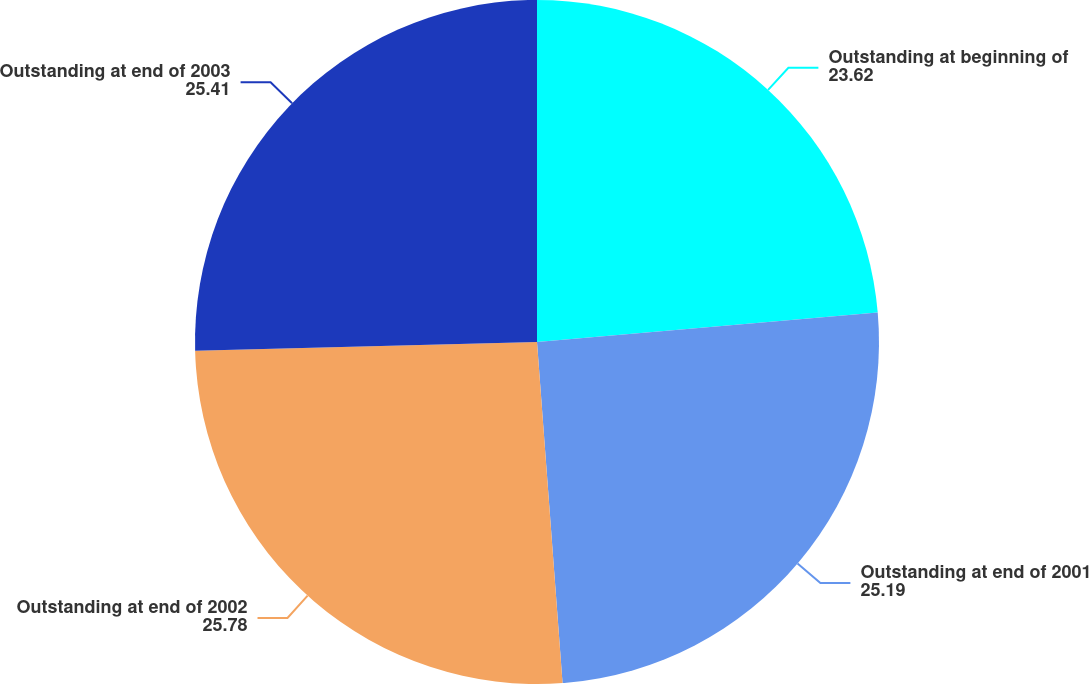Convert chart. <chart><loc_0><loc_0><loc_500><loc_500><pie_chart><fcel>Outstanding at beginning of<fcel>Outstanding at end of 2001<fcel>Outstanding at end of 2002<fcel>Outstanding at end of 2003<nl><fcel>23.62%<fcel>25.19%<fcel>25.78%<fcel>25.41%<nl></chart> 